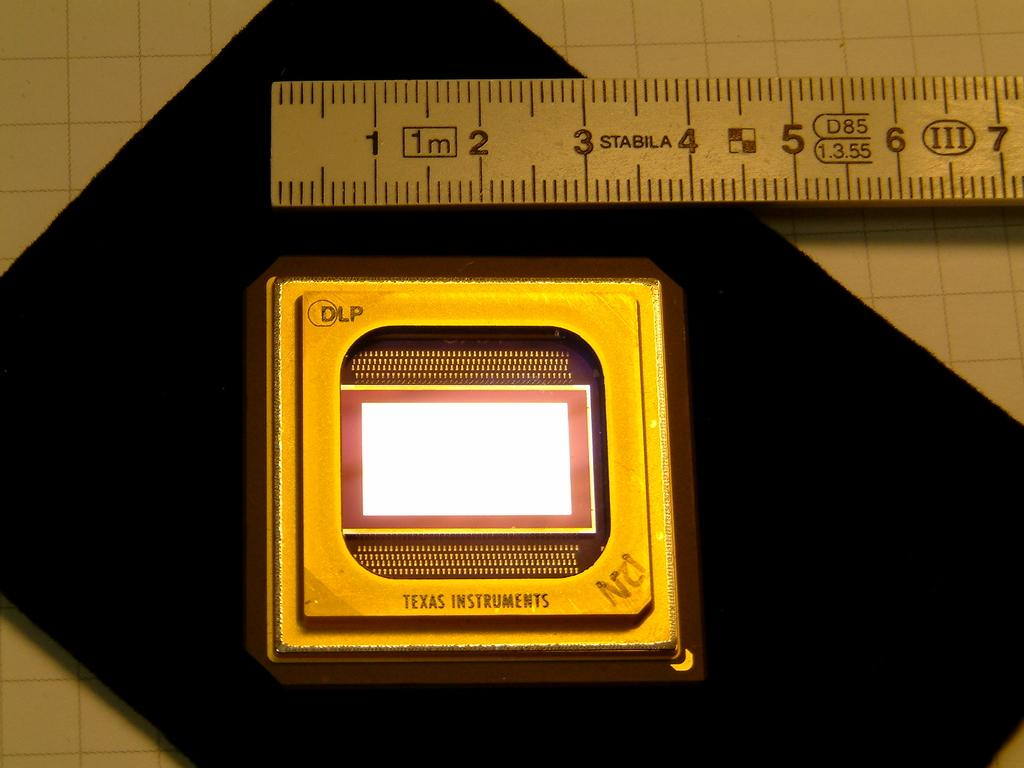<image>
Share a concise interpretation of the image provided. The Texas Instuments chip is about 4 centimeters on each end. 